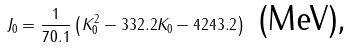Convert formula to latex. <formula><loc_0><loc_0><loc_500><loc_500>J _ { 0 } = \frac { 1 } { 7 0 . 1 } \left ( K _ { 0 } ^ { 2 } - 3 3 2 . 2 K _ { 0 } - 4 2 4 3 . 2 \right ) \text { (MeV),}</formula> 